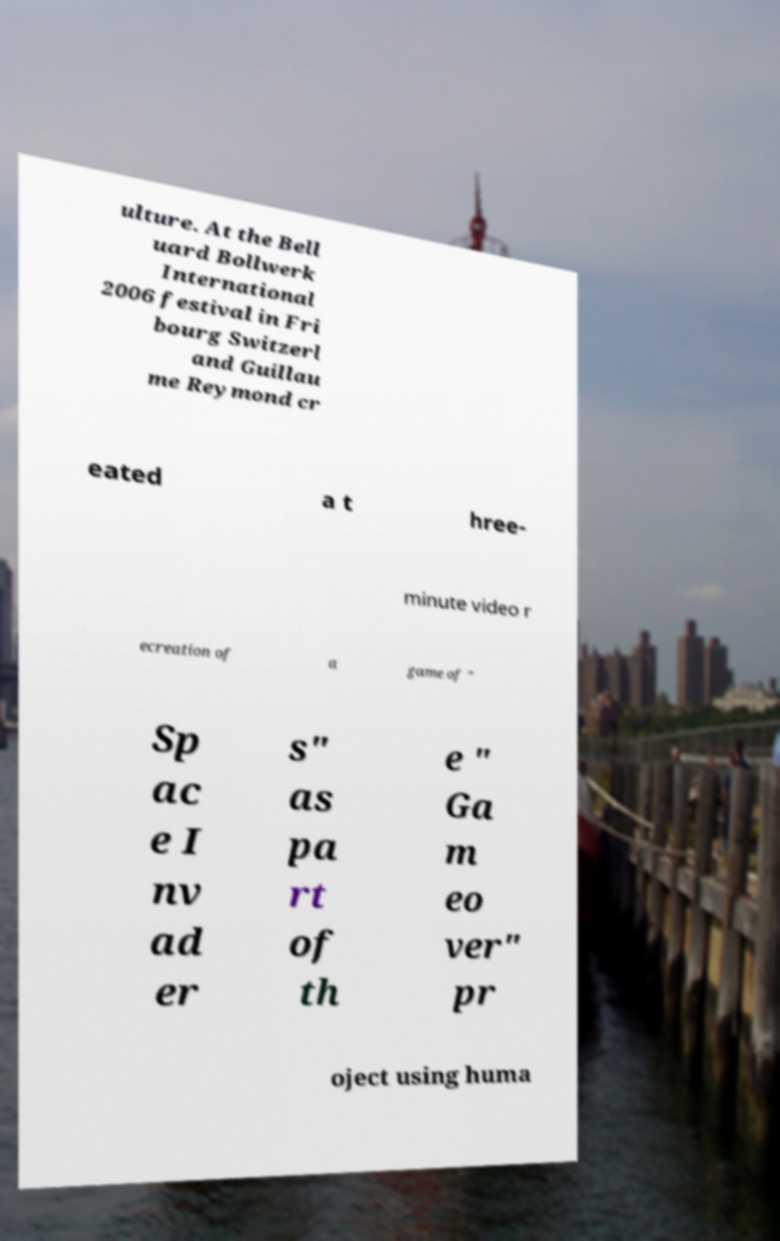Please read and relay the text visible in this image. What does it say? ulture. At the Bell uard Bollwerk International 2006 festival in Fri bourg Switzerl and Guillau me Reymond cr eated a t hree- minute video r ecreation of a game of " Sp ac e I nv ad er s" as pa rt of th e " Ga m eo ver" pr oject using huma 